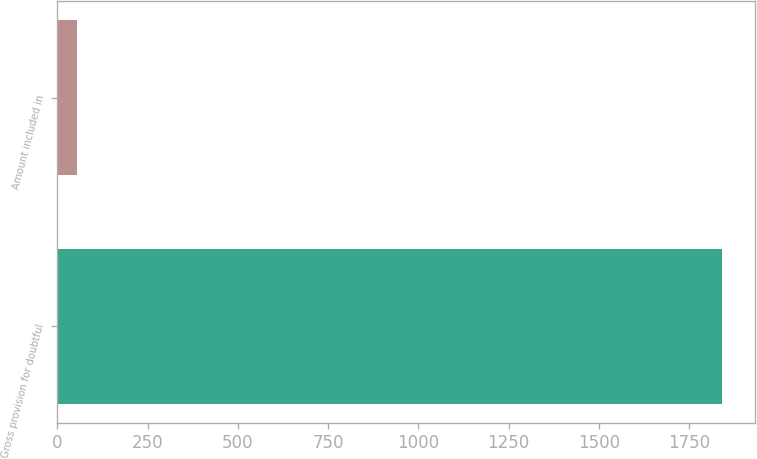Convert chart. <chart><loc_0><loc_0><loc_500><loc_500><bar_chart><fcel>Gross provision for doubtful<fcel>Amount included in<nl><fcel>1841<fcel>53<nl></chart> 